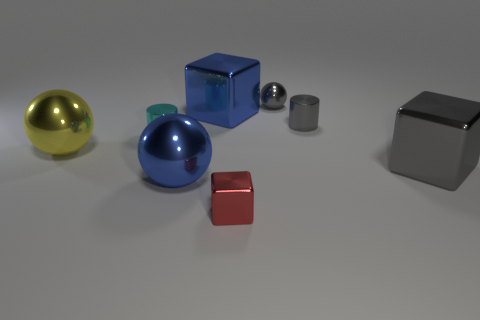What is the size of the metallic cube that is the same color as the tiny metal ball?
Your answer should be very brief. Large. Is there a object that has the same size as the gray cylinder?
Provide a short and direct response. Yes. There is a large yellow shiny ball; what number of metal objects are in front of it?
Give a very brief answer. 3. Do the cyan thing that is behind the large gray cube and the large yellow object have the same shape?
Make the answer very short. No. Are there any cyan metallic objects of the same shape as the large gray metal object?
Offer a terse response. No. There is a tiny cylinder that is the same color as the tiny shiny ball; what is it made of?
Give a very brief answer. Metal. The gray object on the left side of the metal cylinder that is to the right of the cyan shiny object is what shape?
Your response must be concise. Sphere. How many other tiny gray balls have the same material as the gray ball?
Your answer should be compact. 0. There is a tiny ball that is made of the same material as the gray cube; what color is it?
Your answer should be compact. Gray. There is a cube that is to the left of the metallic block that is in front of the big metallic cube that is on the right side of the red shiny thing; what is its size?
Provide a short and direct response. Large. 